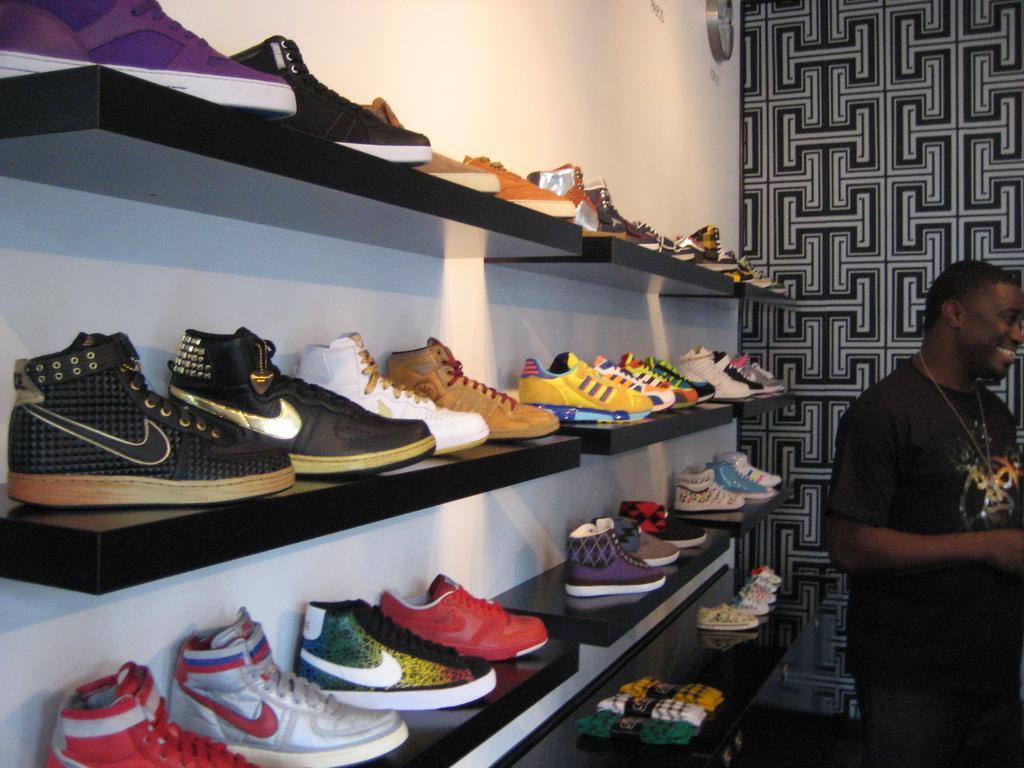Can you describe this image briefly? In the foreground I can see different types of shoes are kept in shelves and a person is standing on the floor. In the background I can see a wall and a clock. This image is taken may be in a shop. 